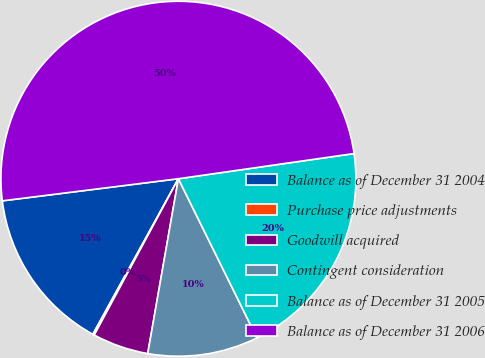Convert chart to OTSL. <chart><loc_0><loc_0><loc_500><loc_500><pie_chart><fcel>Balance as of December 31 2004<fcel>Purchase price adjustments<fcel>Goodwill acquired<fcel>Contingent consideration<fcel>Balance as of December 31 2005<fcel>Balance as of December 31 2006<nl><fcel>15.01%<fcel>0.14%<fcel>5.1%<fcel>10.06%<fcel>19.97%<fcel>49.72%<nl></chart> 